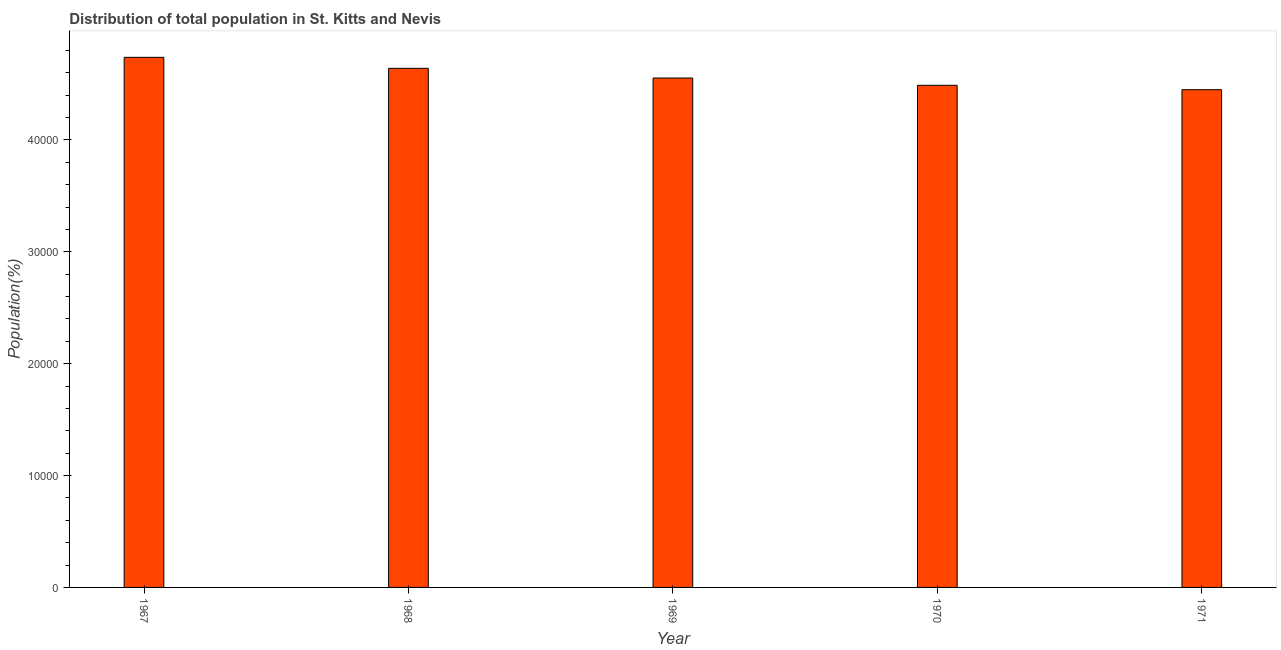What is the title of the graph?
Provide a short and direct response. Distribution of total population in St. Kitts and Nevis . What is the label or title of the X-axis?
Provide a short and direct response. Year. What is the label or title of the Y-axis?
Make the answer very short. Population(%). What is the population in 1967?
Ensure brevity in your answer.  4.74e+04. Across all years, what is the maximum population?
Make the answer very short. 4.74e+04. Across all years, what is the minimum population?
Ensure brevity in your answer.  4.45e+04. In which year was the population maximum?
Ensure brevity in your answer.  1967. In which year was the population minimum?
Your answer should be compact. 1971. What is the sum of the population?
Make the answer very short. 2.29e+05. What is the difference between the population in 1968 and 1970?
Your answer should be compact. 1517. What is the average population per year?
Your response must be concise. 4.57e+04. What is the median population?
Offer a terse response. 4.55e+04. In how many years, is the population greater than 14000 %?
Ensure brevity in your answer.  5. What is the ratio of the population in 1970 to that in 1971?
Offer a terse response. 1.01. Is the population in 1967 less than that in 1969?
Make the answer very short. No. Is the difference between the population in 1969 and 1971 greater than the difference between any two years?
Offer a terse response. No. What is the difference between the highest and the second highest population?
Ensure brevity in your answer.  984. Is the sum of the population in 1970 and 1971 greater than the maximum population across all years?
Your answer should be compact. Yes. What is the difference between the highest and the lowest population?
Provide a short and direct response. 2893. In how many years, is the population greater than the average population taken over all years?
Offer a terse response. 2. How many bars are there?
Offer a very short reply. 5. Are all the bars in the graph horizontal?
Your answer should be compact. No. Are the values on the major ticks of Y-axis written in scientific E-notation?
Your answer should be very brief. No. What is the Population(%) of 1967?
Provide a succinct answer. 4.74e+04. What is the Population(%) in 1968?
Make the answer very short. 4.64e+04. What is the Population(%) of 1969?
Offer a very short reply. 4.55e+04. What is the Population(%) in 1970?
Make the answer very short. 4.49e+04. What is the Population(%) of 1971?
Ensure brevity in your answer.  4.45e+04. What is the difference between the Population(%) in 1967 and 1968?
Ensure brevity in your answer.  984. What is the difference between the Population(%) in 1967 and 1969?
Make the answer very short. 1849. What is the difference between the Population(%) in 1967 and 1970?
Your answer should be very brief. 2501. What is the difference between the Population(%) in 1967 and 1971?
Your response must be concise. 2893. What is the difference between the Population(%) in 1968 and 1969?
Offer a very short reply. 865. What is the difference between the Population(%) in 1968 and 1970?
Your response must be concise. 1517. What is the difference between the Population(%) in 1968 and 1971?
Offer a terse response. 1909. What is the difference between the Population(%) in 1969 and 1970?
Your answer should be very brief. 652. What is the difference between the Population(%) in 1969 and 1971?
Keep it short and to the point. 1044. What is the difference between the Population(%) in 1970 and 1971?
Make the answer very short. 392. What is the ratio of the Population(%) in 1967 to that in 1968?
Your answer should be very brief. 1.02. What is the ratio of the Population(%) in 1967 to that in 1969?
Your answer should be very brief. 1.04. What is the ratio of the Population(%) in 1967 to that in 1970?
Provide a succinct answer. 1.06. What is the ratio of the Population(%) in 1967 to that in 1971?
Give a very brief answer. 1.06. What is the ratio of the Population(%) in 1968 to that in 1969?
Provide a succinct answer. 1.02. What is the ratio of the Population(%) in 1968 to that in 1970?
Make the answer very short. 1.03. What is the ratio of the Population(%) in 1968 to that in 1971?
Provide a succinct answer. 1.04. What is the ratio of the Population(%) in 1969 to that in 1970?
Give a very brief answer. 1.01. What is the ratio of the Population(%) in 1970 to that in 1971?
Make the answer very short. 1.01. 